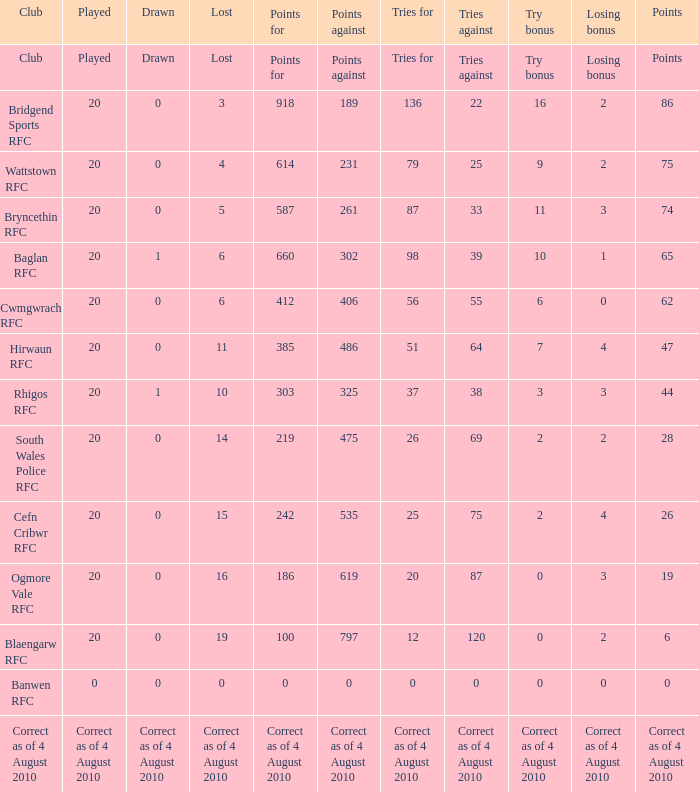What is the points against when the losing bonus is 0 and the club is banwen rfc? 0.0. 